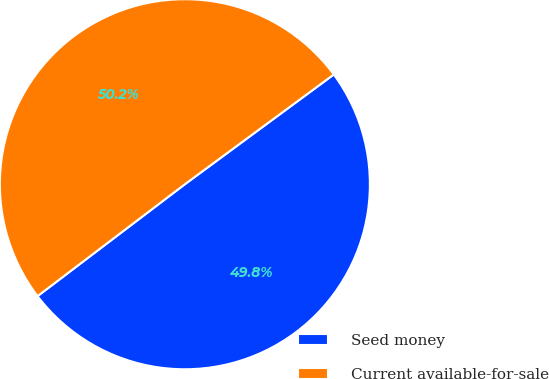Convert chart. <chart><loc_0><loc_0><loc_500><loc_500><pie_chart><fcel>Seed money<fcel>Current available-for-sale<nl><fcel>49.77%<fcel>50.23%<nl></chart> 